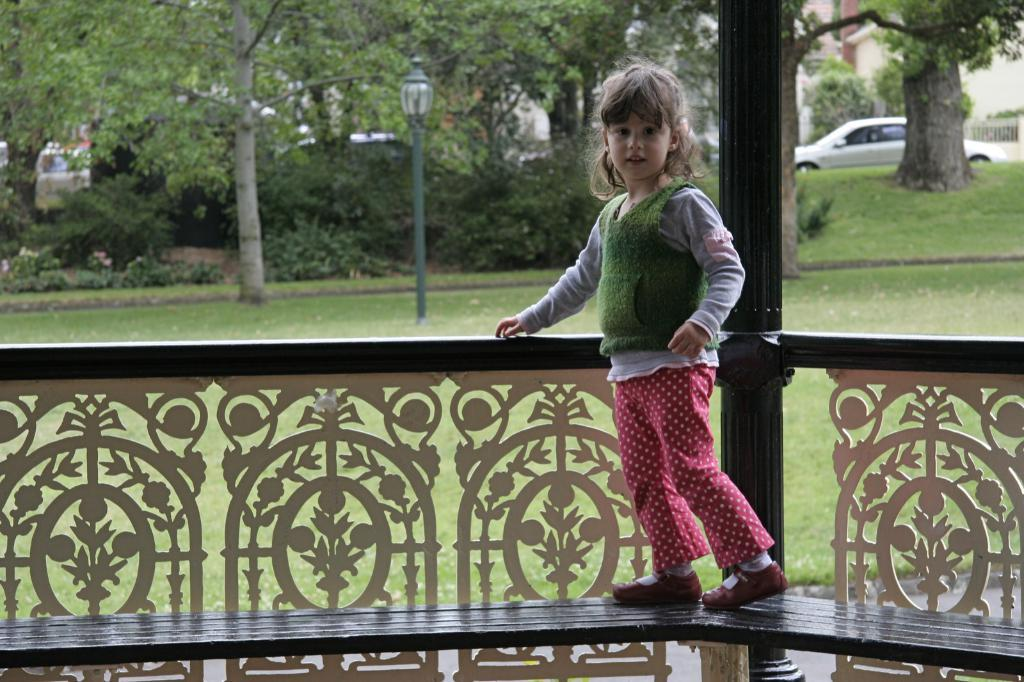Who is the main subject in the picture? There is a girl in the picture. What is the girl doing in the image? The girl is standing on a bench. Where is the bench located in relation to other objects? The bench is near a railing. What can be seen in the background of the image? There is light, trees, plants, cats, and a wall in the background of the image. What class is the girl attending in the image? There is no indication of a class or any educational setting in the image. 